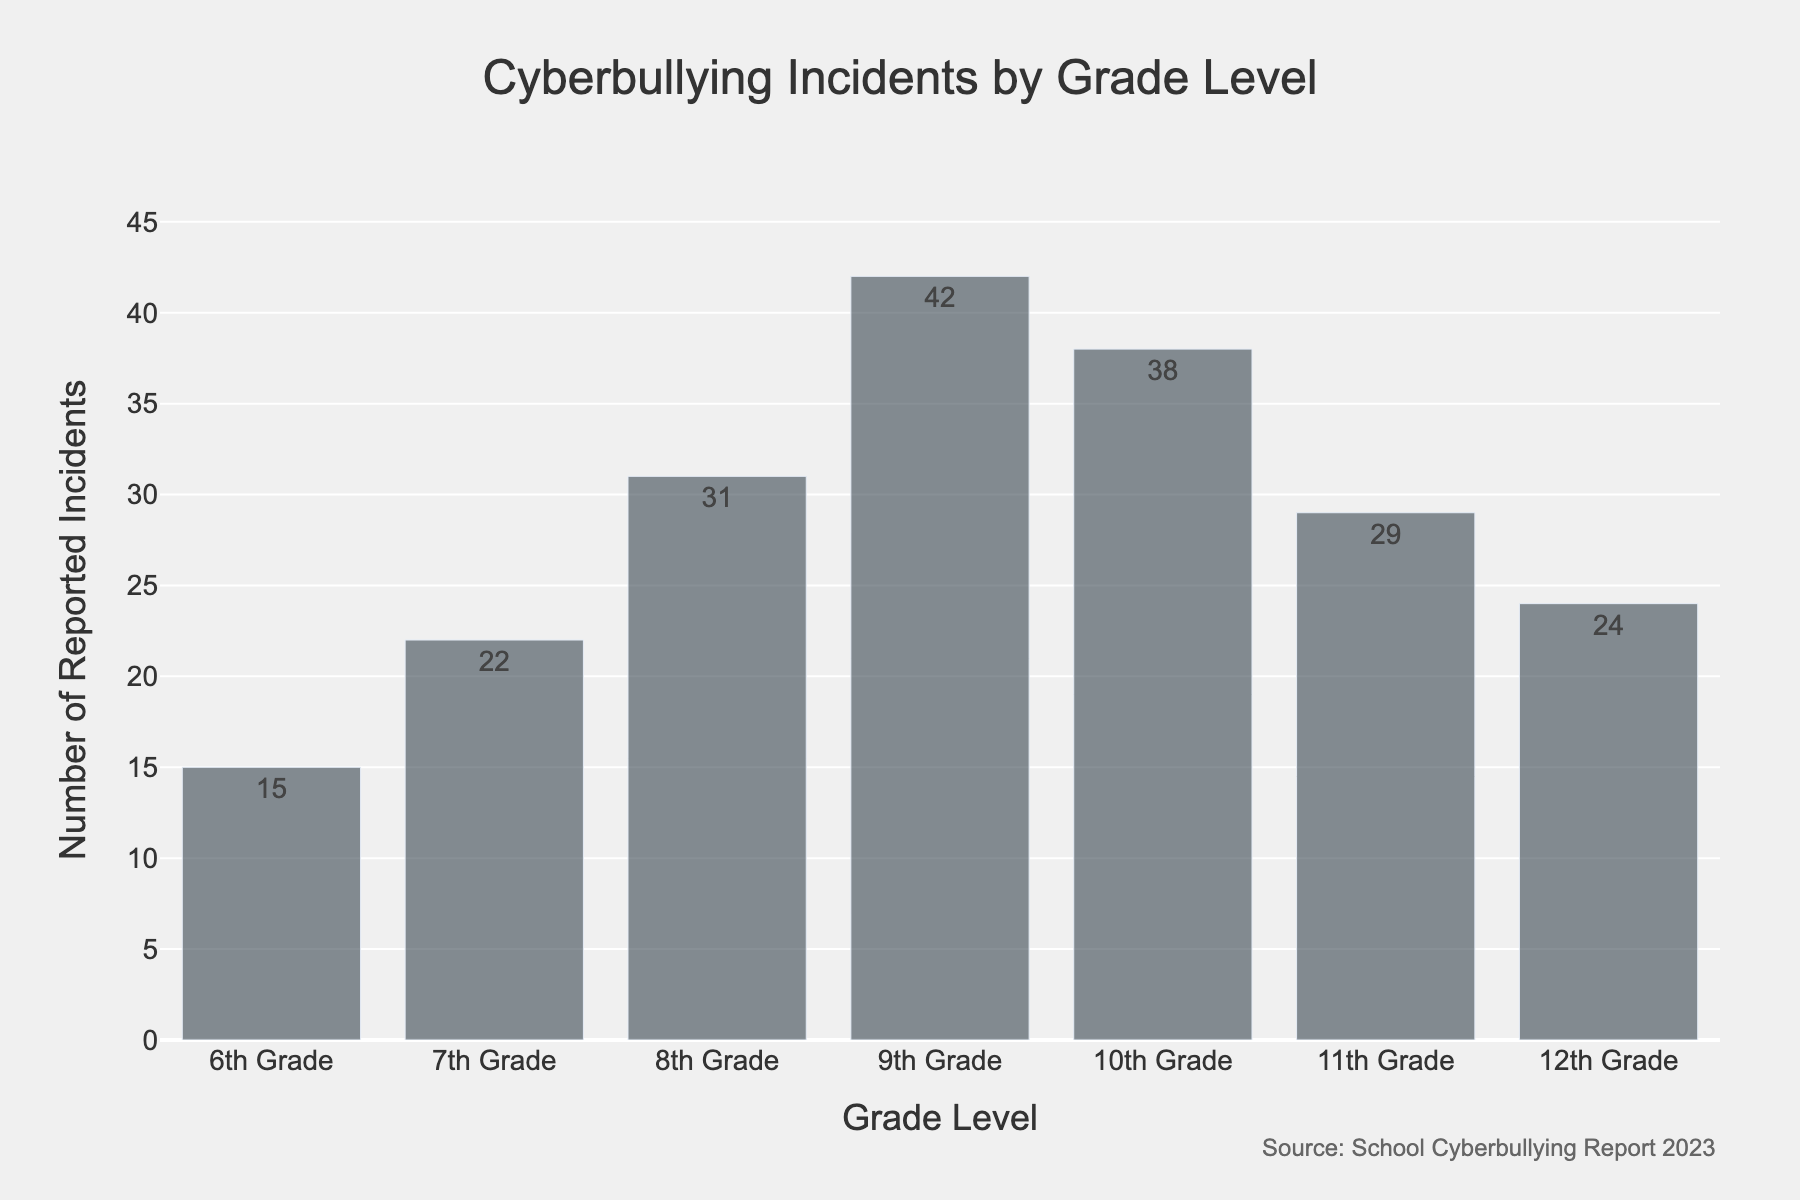What is the title of the histogram? The title is written at the top of the figure and is clearly readable.
Answer: Cyberbullying Incidents by Grade Level Which grade level has the highest number of reported cyberbullying incidents? Look at the bar that reaches the highest point on the y-axis.
Answer: 9th Grade How many cyberbullying incidents were reported in the 12th grade? Check the height of the bar corresponding to the 12th Grade on the x-axis.
Answer: 24 What is the difference in the number of reported cyberbullying incidents between the 9th and 10th grades? Subtract the number of incidents in the 10th grade from the number in the 9th grade. The numbers are 42 for 9th grade and 38 for 10th grade.
Answer: 4 What is the average number of reported cyberbullying incidents across all grades? Sum all the reported incidents and then divide by the number of grade levels (7). (15 + 22 + 31 + 42 + 38 + 29 + 24) / 7 = 201 / 7 = 28.71
Answer: 28.71 Which two consecutive grade levels exhibit the smallest difference in the number of reported cyberbullying incidents? Compare the differences between each pair of consecutive grades' incident counts and identify the smallest one. Differences are as follows: 6th-7th: 7, 7th-8th: 9, 8th-9th: 11, 9th-10th: 4, 10th-11th: 9, 11th-12th: 5. Thus, the smallest difference is between 9th and 10th grades.
Answer: 9th Grade and 10th Grade Aside from the 9th grade, which grade has reported the most cyberbullying incidents? Find the next highest bar after identifying the 9th grade as the highest.
Answer: 10th Grade What is the total sum of reported cyberbullying incidents in the middle school grades (6th to 8th)? Add the number of reported incidents from 6th, 7th, and 8th grades. (15 + 22 + 31) = 68
Answer: 68 How many grades have reported more than 30 cyberbullying incidents? Count the number of bars that exceed the 30 mark on the y-axis.
Answer: 3 What is the source of the data used in the histogram? The source is provided as an annotation in the figure.
Answer: School Cyberbullying Report 2023 